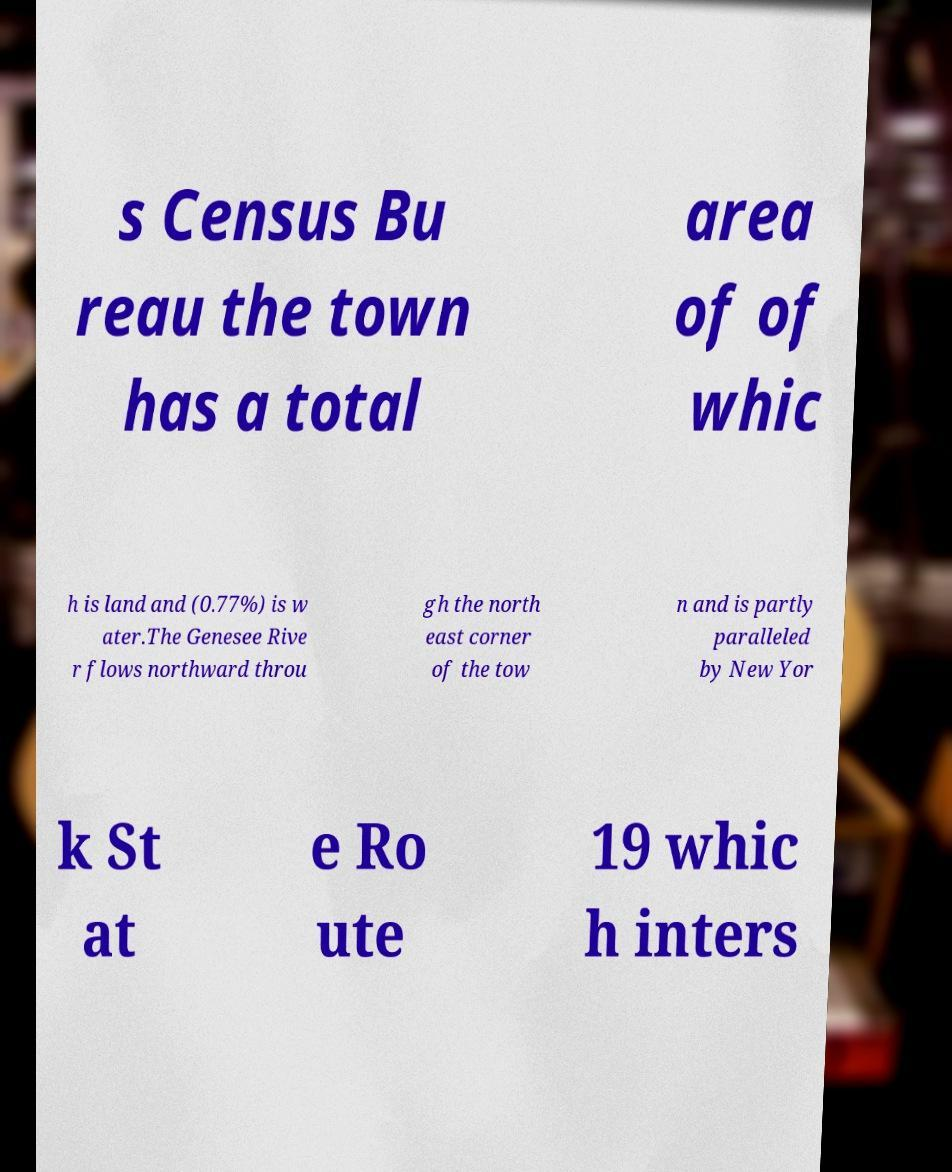Can you read and provide the text displayed in the image?This photo seems to have some interesting text. Can you extract and type it out for me? s Census Bu reau the town has a total area of of whic h is land and (0.77%) is w ater.The Genesee Rive r flows northward throu gh the north east corner of the tow n and is partly paralleled by New Yor k St at e Ro ute 19 whic h inters 